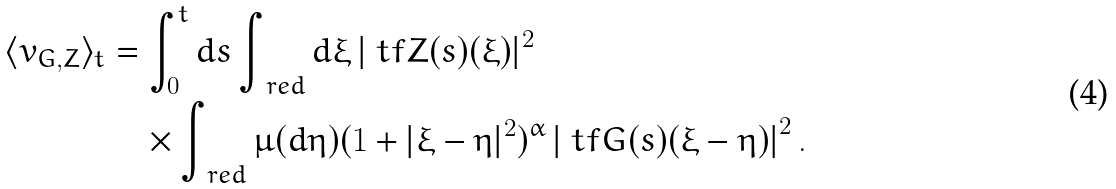Convert formula to latex. <formula><loc_0><loc_0><loc_500><loc_500>\langle v _ { G , Z } \rangle _ { t } & = \int _ { 0 } ^ { t } d s \int _ { \ r e d } d \xi \, | \ t f Z ( s ) ( \xi ) | ^ { 2 } \\ & \quad \times \int _ { \ r e d } \mu ( d \eta ) ( 1 + | \xi - \eta | ^ { 2 } ) ^ { \alpha } \left | \ t f G ( s ) ( \xi - \eta ) \right | ^ { 2 } .</formula> 